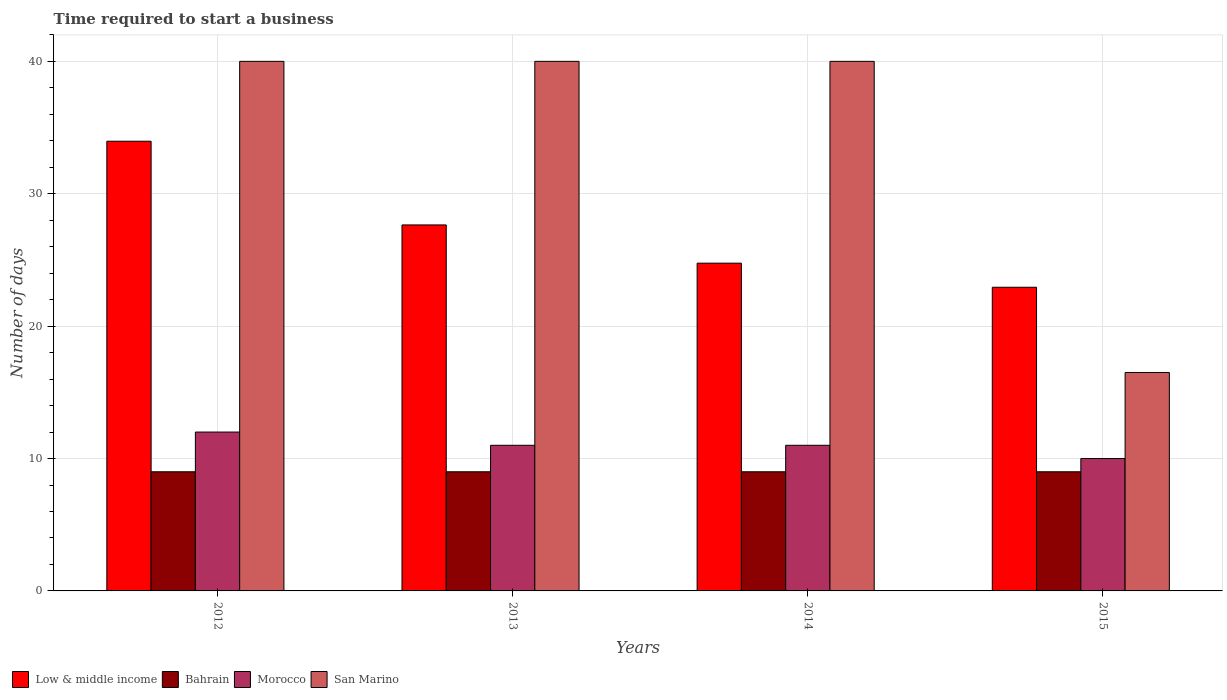How many groups of bars are there?
Ensure brevity in your answer.  4. Are the number of bars per tick equal to the number of legend labels?
Provide a succinct answer. Yes. How many bars are there on the 4th tick from the right?
Give a very brief answer. 4. What is the label of the 1st group of bars from the left?
Your response must be concise. 2012. Across all years, what is the maximum number of days required to start a business in San Marino?
Provide a succinct answer. 40. Across all years, what is the minimum number of days required to start a business in San Marino?
Make the answer very short. 16.5. What is the total number of days required to start a business in San Marino in the graph?
Your response must be concise. 136.5. What is the difference between the number of days required to start a business in Morocco in 2013 and that in 2015?
Your answer should be very brief. 1. What is the difference between the number of days required to start a business in Low & middle income in 2012 and the number of days required to start a business in San Marino in 2013?
Provide a short and direct response. -6.03. What is the average number of days required to start a business in San Marino per year?
Provide a short and direct response. 34.12. In the year 2013, what is the difference between the number of days required to start a business in Low & middle income and number of days required to start a business in Bahrain?
Your answer should be very brief. 18.64. What is the ratio of the number of days required to start a business in Low & middle income in 2012 to that in 2014?
Your answer should be very brief. 1.37. What is the difference between the highest and the second highest number of days required to start a business in Morocco?
Provide a succinct answer. 1. What is the difference between the highest and the lowest number of days required to start a business in Low & middle income?
Offer a terse response. 11.03. In how many years, is the number of days required to start a business in Low & middle income greater than the average number of days required to start a business in Low & middle income taken over all years?
Your response must be concise. 2. Is it the case that in every year, the sum of the number of days required to start a business in Morocco and number of days required to start a business in Low & middle income is greater than the sum of number of days required to start a business in Bahrain and number of days required to start a business in San Marino?
Give a very brief answer. Yes. What does the 4th bar from the left in 2014 represents?
Your answer should be compact. San Marino. What does the 3rd bar from the right in 2015 represents?
Your answer should be compact. Bahrain. Is it the case that in every year, the sum of the number of days required to start a business in San Marino and number of days required to start a business in Bahrain is greater than the number of days required to start a business in Morocco?
Make the answer very short. Yes. How many bars are there?
Give a very brief answer. 16. Are all the bars in the graph horizontal?
Provide a succinct answer. No. How many years are there in the graph?
Offer a very short reply. 4. What is the difference between two consecutive major ticks on the Y-axis?
Keep it short and to the point. 10. Are the values on the major ticks of Y-axis written in scientific E-notation?
Ensure brevity in your answer.  No. Does the graph contain any zero values?
Your answer should be compact. No. Does the graph contain grids?
Ensure brevity in your answer.  Yes. How many legend labels are there?
Give a very brief answer. 4. What is the title of the graph?
Your response must be concise. Time required to start a business. Does "Maldives" appear as one of the legend labels in the graph?
Keep it short and to the point. No. What is the label or title of the Y-axis?
Keep it short and to the point. Number of days. What is the Number of days in Low & middle income in 2012?
Make the answer very short. 33.97. What is the Number of days in Bahrain in 2012?
Keep it short and to the point. 9. What is the Number of days of Low & middle income in 2013?
Keep it short and to the point. 27.64. What is the Number of days of Morocco in 2013?
Your answer should be compact. 11. What is the Number of days of Low & middle income in 2014?
Make the answer very short. 24.76. What is the Number of days in Morocco in 2014?
Ensure brevity in your answer.  11. What is the Number of days in Low & middle income in 2015?
Provide a short and direct response. 22.94. What is the Number of days of Morocco in 2015?
Keep it short and to the point. 10. What is the Number of days in San Marino in 2015?
Provide a short and direct response. 16.5. Across all years, what is the maximum Number of days of Low & middle income?
Your response must be concise. 33.97. Across all years, what is the maximum Number of days in Bahrain?
Make the answer very short. 9. Across all years, what is the maximum Number of days of San Marino?
Give a very brief answer. 40. Across all years, what is the minimum Number of days in Low & middle income?
Provide a short and direct response. 22.94. Across all years, what is the minimum Number of days in Morocco?
Offer a very short reply. 10. Across all years, what is the minimum Number of days in San Marino?
Keep it short and to the point. 16.5. What is the total Number of days of Low & middle income in the graph?
Provide a succinct answer. 109.3. What is the total Number of days of Bahrain in the graph?
Your answer should be compact. 36. What is the total Number of days of San Marino in the graph?
Provide a short and direct response. 136.5. What is the difference between the Number of days of Low & middle income in 2012 and that in 2013?
Provide a short and direct response. 6.32. What is the difference between the Number of days in Bahrain in 2012 and that in 2013?
Your answer should be compact. 0. What is the difference between the Number of days of Morocco in 2012 and that in 2013?
Ensure brevity in your answer.  1. What is the difference between the Number of days of Low & middle income in 2012 and that in 2014?
Your answer should be compact. 9.21. What is the difference between the Number of days of Morocco in 2012 and that in 2014?
Your answer should be compact. 1. What is the difference between the Number of days in Low & middle income in 2012 and that in 2015?
Your response must be concise. 11.03. What is the difference between the Number of days of Low & middle income in 2013 and that in 2014?
Your response must be concise. 2.89. What is the difference between the Number of days of Bahrain in 2013 and that in 2014?
Provide a succinct answer. 0. What is the difference between the Number of days of Morocco in 2013 and that in 2014?
Provide a short and direct response. 0. What is the difference between the Number of days of Low & middle income in 2013 and that in 2015?
Make the answer very short. 4.71. What is the difference between the Number of days in Bahrain in 2013 and that in 2015?
Keep it short and to the point. 0. What is the difference between the Number of days of San Marino in 2013 and that in 2015?
Your response must be concise. 23.5. What is the difference between the Number of days in Low & middle income in 2014 and that in 2015?
Your answer should be compact. 1.82. What is the difference between the Number of days in Morocco in 2014 and that in 2015?
Offer a terse response. 1. What is the difference between the Number of days in San Marino in 2014 and that in 2015?
Give a very brief answer. 23.5. What is the difference between the Number of days in Low & middle income in 2012 and the Number of days in Bahrain in 2013?
Your answer should be compact. 24.97. What is the difference between the Number of days of Low & middle income in 2012 and the Number of days of Morocco in 2013?
Provide a short and direct response. 22.97. What is the difference between the Number of days of Low & middle income in 2012 and the Number of days of San Marino in 2013?
Keep it short and to the point. -6.03. What is the difference between the Number of days of Bahrain in 2012 and the Number of days of San Marino in 2013?
Offer a terse response. -31. What is the difference between the Number of days in Morocco in 2012 and the Number of days in San Marino in 2013?
Keep it short and to the point. -28. What is the difference between the Number of days in Low & middle income in 2012 and the Number of days in Bahrain in 2014?
Provide a succinct answer. 24.97. What is the difference between the Number of days in Low & middle income in 2012 and the Number of days in Morocco in 2014?
Your answer should be compact. 22.97. What is the difference between the Number of days in Low & middle income in 2012 and the Number of days in San Marino in 2014?
Ensure brevity in your answer.  -6.03. What is the difference between the Number of days of Bahrain in 2012 and the Number of days of Morocco in 2014?
Ensure brevity in your answer.  -2. What is the difference between the Number of days in Bahrain in 2012 and the Number of days in San Marino in 2014?
Offer a terse response. -31. What is the difference between the Number of days in Low & middle income in 2012 and the Number of days in Bahrain in 2015?
Your response must be concise. 24.97. What is the difference between the Number of days of Low & middle income in 2012 and the Number of days of Morocco in 2015?
Make the answer very short. 23.97. What is the difference between the Number of days of Low & middle income in 2012 and the Number of days of San Marino in 2015?
Make the answer very short. 17.47. What is the difference between the Number of days of Bahrain in 2012 and the Number of days of Morocco in 2015?
Make the answer very short. -1. What is the difference between the Number of days of Low & middle income in 2013 and the Number of days of Bahrain in 2014?
Provide a succinct answer. 18.64. What is the difference between the Number of days in Low & middle income in 2013 and the Number of days in Morocco in 2014?
Your answer should be very brief. 16.64. What is the difference between the Number of days of Low & middle income in 2013 and the Number of days of San Marino in 2014?
Ensure brevity in your answer.  -12.36. What is the difference between the Number of days in Bahrain in 2013 and the Number of days in San Marino in 2014?
Ensure brevity in your answer.  -31. What is the difference between the Number of days in Morocco in 2013 and the Number of days in San Marino in 2014?
Your answer should be very brief. -29. What is the difference between the Number of days of Low & middle income in 2013 and the Number of days of Bahrain in 2015?
Make the answer very short. 18.64. What is the difference between the Number of days in Low & middle income in 2013 and the Number of days in Morocco in 2015?
Keep it short and to the point. 17.64. What is the difference between the Number of days in Low & middle income in 2013 and the Number of days in San Marino in 2015?
Your answer should be compact. 11.14. What is the difference between the Number of days in Bahrain in 2013 and the Number of days in Morocco in 2015?
Provide a succinct answer. -1. What is the difference between the Number of days of Bahrain in 2013 and the Number of days of San Marino in 2015?
Give a very brief answer. -7.5. What is the difference between the Number of days of Low & middle income in 2014 and the Number of days of Bahrain in 2015?
Give a very brief answer. 15.76. What is the difference between the Number of days in Low & middle income in 2014 and the Number of days in Morocco in 2015?
Provide a succinct answer. 14.76. What is the difference between the Number of days of Low & middle income in 2014 and the Number of days of San Marino in 2015?
Give a very brief answer. 8.26. What is the difference between the Number of days of Bahrain in 2014 and the Number of days of San Marino in 2015?
Provide a succinct answer. -7.5. What is the difference between the Number of days of Morocco in 2014 and the Number of days of San Marino in 2015?
Keep it short and to the point. -5.5. What is the average Number of days of Low & middle income per year?
Ensure brevity in your answer.  27.33. What is the average Number of days of Bahrain per year?
Provide a short and direct response. 9. What is the average Number of days of San Marino per year?
Make the answer very short. 34.12. In the year 2012, what is the difference between the Number of days of Low & middle income and Number of days of Bahrain?
Offer a terse response. 24.97. In the year 2012, what is the difference between the Number of days in Low & middle income and Number of days in Morocco?
Your response must be concise. 21.97. In the year 2012, what is the difference between the Number of days in Low & middle income and Number of days in San Marino?
Keep it short and to the point. -6.03. In the year 2012, what is the difference between the Number of days in Bahrain and Number of days in San Marino?
Offer a very short reply. -31. In the year 2012, what is the difference between the Number of days in Morocco and Number of days in San Marino?
Offer a terse response. -28. In the year 2013, what is the difference between the Number of days of Low & middle income and Number of days of Bahrain?
Offer a very short reply. 18.64. In the year 2013, what is the difference between the Number of days in Low & middle income and Number of days in Morocco?
Offer a terse response. 16.64. In the year 2013, what is the difference between the Number of days in Low & middle income and Number of days in San Marino?
Your response must be concise. -12.36. In the year 2013, what is the difference between the Number of days of Bahrain and Number of days of San Marino?
Offer a very short reply. -31. In the year 2014, what is the difference between the Number of days in Low & middle income and Number of days in Bahrain?
Keep it short and to the point. 15.76. In the year 2014, what is the difference between the Number of days in Low & middle income and Number of days in Morocco?
Make the answer very short. 13.76. In the year 2014, what is the difference between the Number of days of Low & middle income and Number of days of San Marino?
Ensure brevity in your answer.  -15.24. In the year 2014, what is the difference between the Number of days in Bahrain and Number of days in San Marino?
Keep it short and to the point. -31. In the year 2014, what is the difference between the Number of days in Morocco and Number of days in San Marino?
Keep it short and to the point. -29. In the year 2015, what is the difference between the Number of days of Low & middle income and Number of days of Bahrain?
Ensure brevity in your answer.  13.94. In the year 2015, what is the difference between the Number of days of Low & middle income and Number of days of Morocco?
Your answer should be very brief. 12.94. In the year 2015, what is the difference between the Number of days in Low & middle income and Number of days in San Marino?
Your answer should be compact. 6.44. In the year 2015, what is the difference between the Number of days of Bahrain and Number of days of Morocco?
Make the answer very short. -1. In the year 2015, what is the difference between the Number of days of Morocco and Number of days of San Marino?
Your response must be concise. -6.5. What is the ratio of the Number of days in Low & middle income in 2012 to that in 2013?
Your response must be concise. 1.23. What is the ratio of the Number of days of Bahrain in 2012 to that in 2013?
Your answer should be very brief. 1. What is the ratio of the Number of days in Low & middle income in 2012 to that in 2014?
Your answer should be compact. 1.37. What is the ratio of the Number of days of Bahrain in 2012 to that in 2014?
Offer a very short reply. 1. What is the ratio of the Number of days in Morocco in 2012 to that in 2014?
Give a very brief answer. 1.09. What is the ratio of the Number of days of Low & middle income in 2012 to that in 2015?
Give a very brief answer. 1.48. What is the ratio of the Number of days of Bahrain in 2012 to that in 2015?
Provide a short and direct response. 1. What is the ratio of the Number of days in Morocco in 2012 to that in 2015?
Keep it short and to the point. 1.2. What is the ratio of the Number of days of San Marino in 2012 to that in 2015?
Your answer should be compact. 2.42. What is the ratio of the Number of days of Low & middle income in 2013 to that in 2014?
Ensure brevity in your answer.  1.12. What is the ratio of the Number of days of Bahrain in 2013 to that in 2014?
Give a very brief answer. 1. What is the ratio of the Number of days in San Marino in 2013 to that in 2014?
Provide a short and direct response. 1. What is the ratio of the Number of days in Low & middle income in 2013 to that in 2015?
Ensure brevity in your answer.  1.21. What is the ratio of the Number of days of Bahrain in 2013 to that in 2015?
Ensure brevity in your answer.  1. What is the ratio of the Number of days of San Marino in 2013 to that in 2015?
Keep it short and to the point. 2.42. What is the ratio of the Number of days of Low & middle income in 2014 to that in 2015?
Make the answer very short. 1.08. What is the ratio of the Number of days in Bahrain in 2014 to that in 2015?
Offer a very short reply. 1. What is the ratio of the Number of days in Morocco in 2014 to that in 2015?
Give a very brief answer. 1.1. What is the ratio of the Number of days of San Marino in 2014 to that in 2015?
Provide a succinct answer. 2.42. What is the difference between the highest and the second highest Number of days of Low & middle income?
Make the answer very short. 6.32. What is the difference between the highest and the second highest Number of days of Bahrain?
Give a very brief answer. 0. What is the difference between the highest and the lowest Number of days of Low & middle income?
Your answer should be compact. 11.03. What is the difference between the highest and the lowest Number of days of Bahrain?
Ensure brevity in your answer.  0. What is the difference between the highest and the lowest Number of days in San Marino?
Provide a succinct answer. 23.5. 